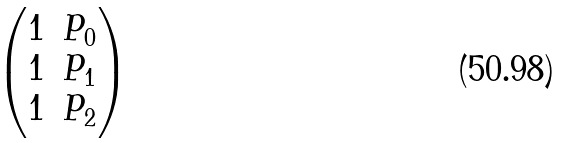Convert formula to latex. <formula><loc_0><loc_0><loc_500><loc_500>\begin{pmatrix} 1 & P _ { 0 } \\ 1 & P _ { 1 } \\ 1 & P _ { 2 } \end{pmatrix}</formula> 